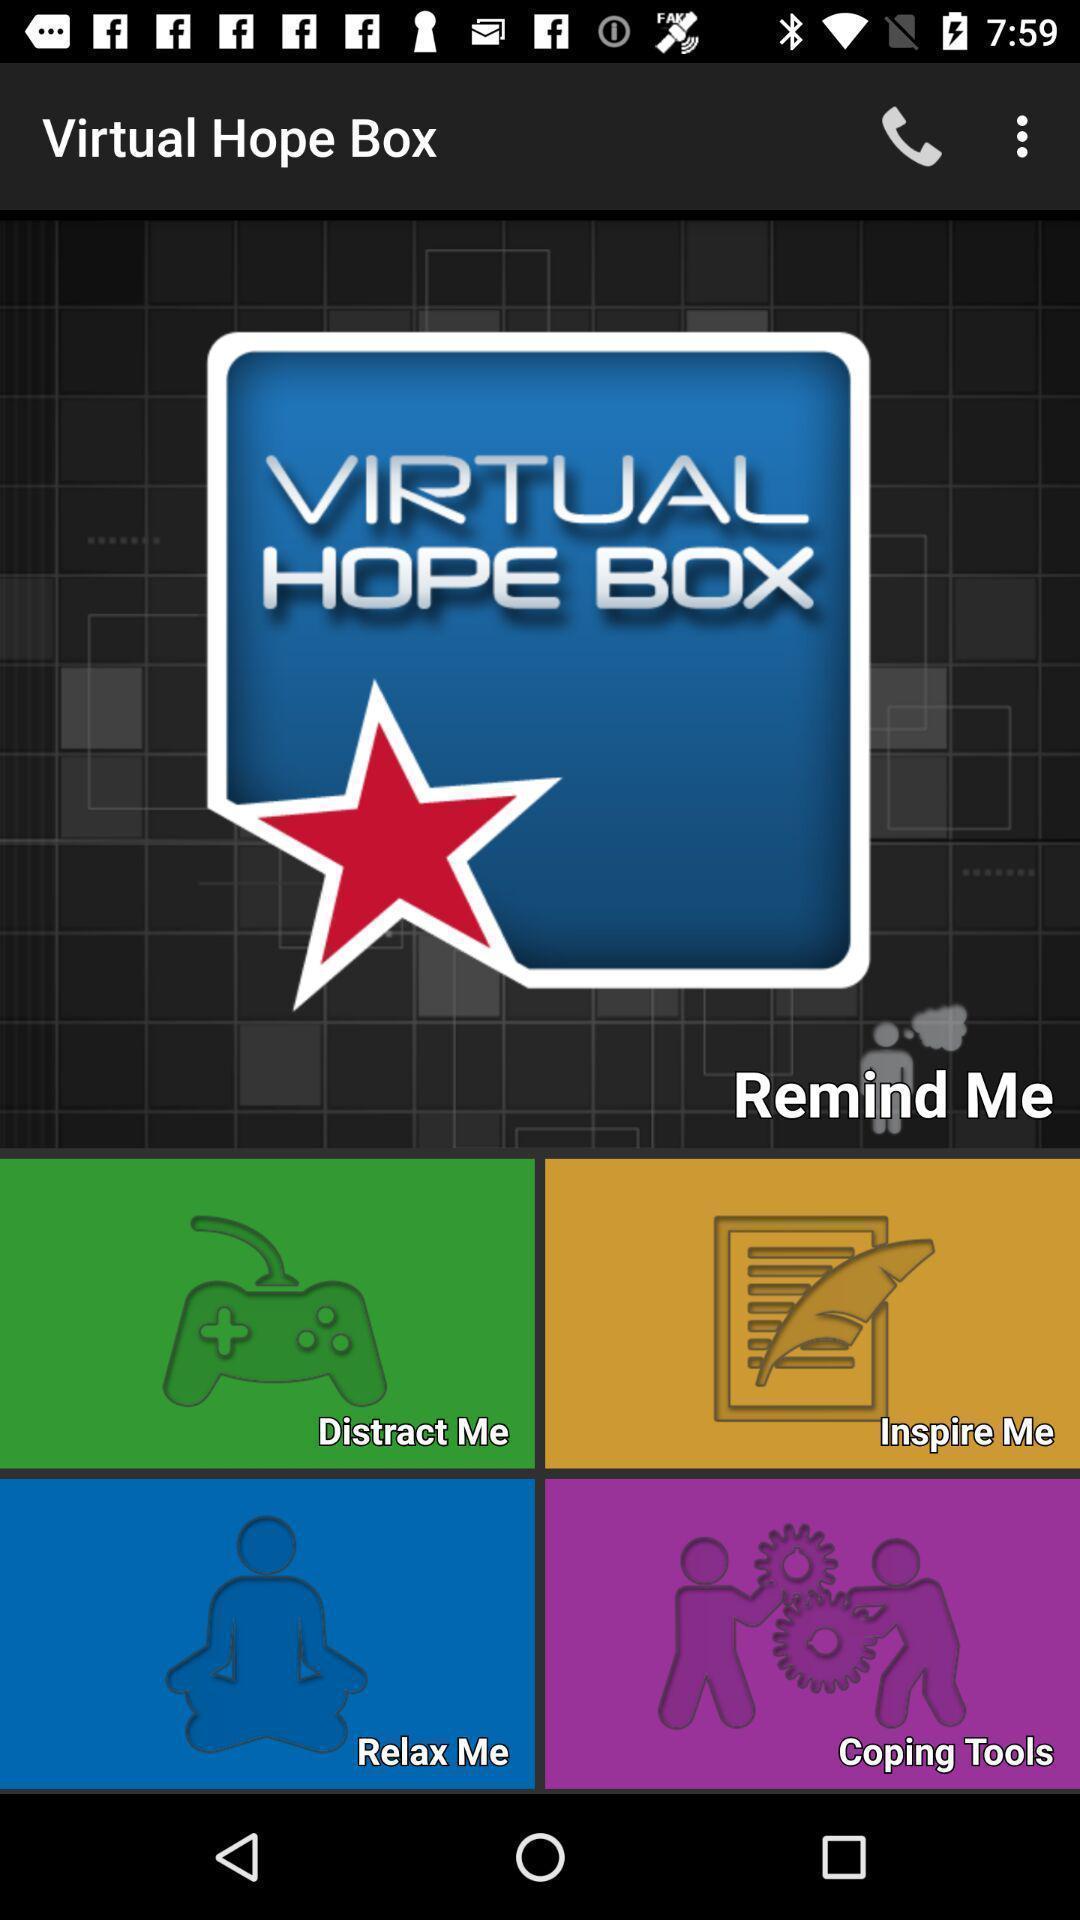Please provide a description for this image. Screen displaying the multiple categories. 